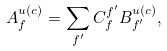Convert formula to latex. <formula><loc_0><loc_0><loc_500><loc_500>A _ { f } ^ { u ( c ) } = \sum _ { f ^ { \prime } } C _ { f } ^ { f ^ { \prime } } B _ { f ^ { \prime } } ^ { u ( c ) } ,</formula> 